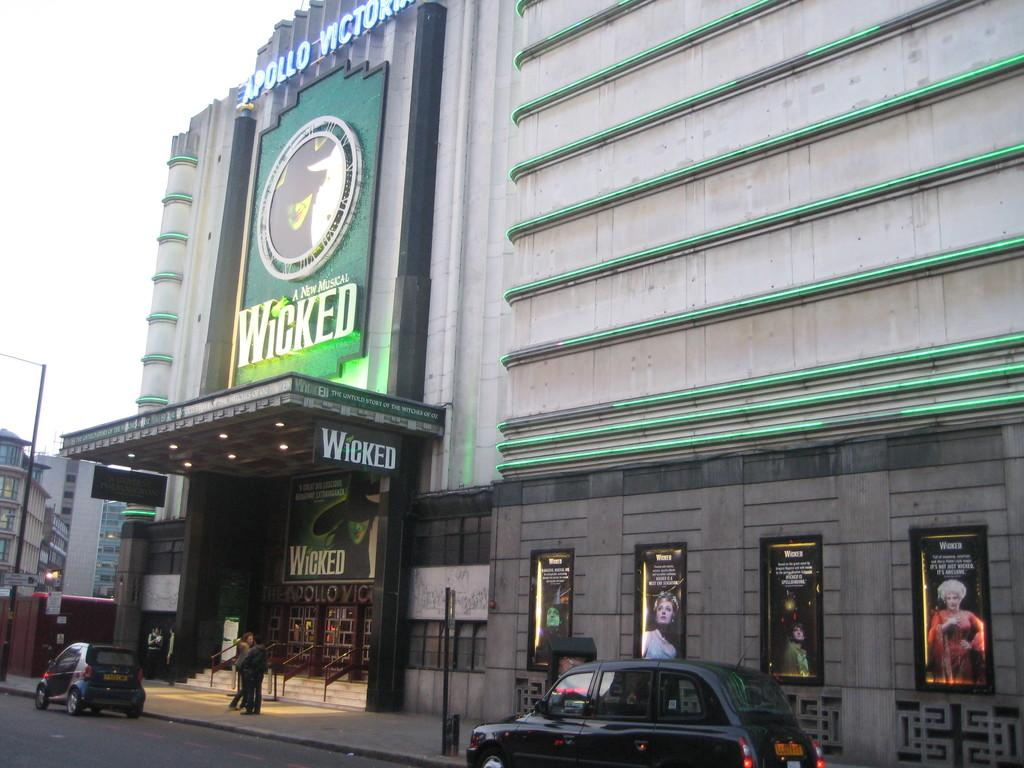<image>
Summarize the visual content of the image. An outside of a movie theater featuring a New Musical Wicked. 